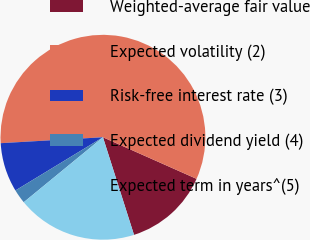Convert chart. <chart><loc_0><loc_0><loc_500><loc_500><pie_chart><fcel>Weighted-average fair value<fcel>Expected volatility (2)<fcel>Risk-free interest rate (3)<fcel>Expected dividend yield (4)<fcel>Expected term in years^(5)<nl><fcel>13.44%<fcel>57.57%<fcel>7.77%<fcel>2.24%<fcel>18.97%<nl></chart> 